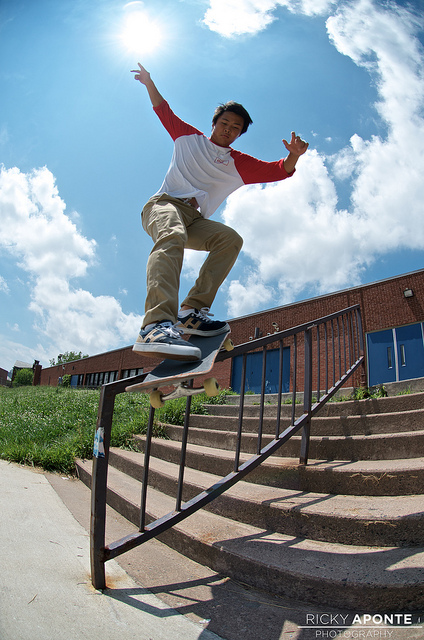Please extract the text content from this image. RICKY APONTE PHOTOGRAPHY 